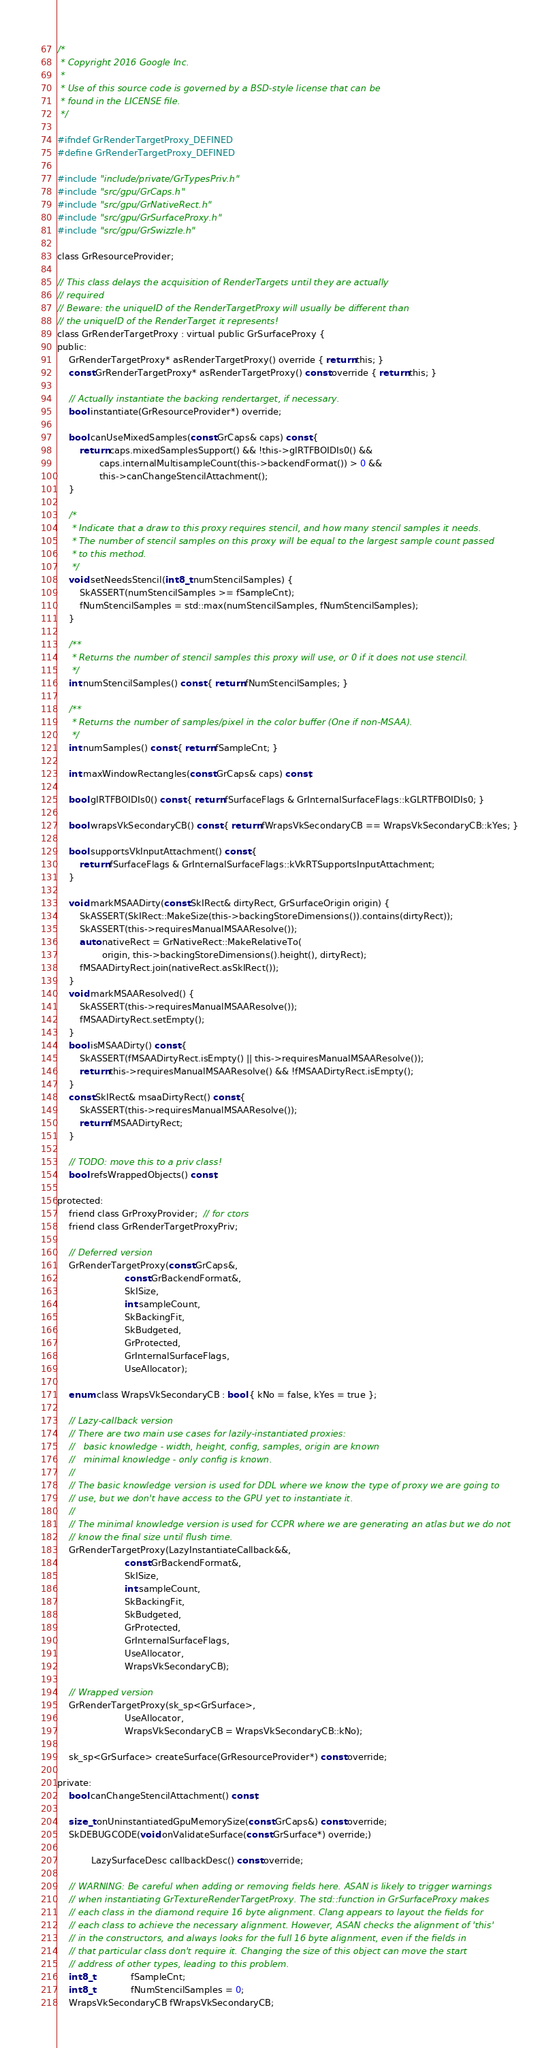Convert code to text. <code><loc_0><loc_0><loc_500><loc_500><_C_>/*
 * Copyright 2016 Google Inc.
 *
 * Use of this source code is governed by a BSD-style license that can be
 * found in the LICENSE file.
 */

#ifndef GrRenderTargetProxy_DEFINED
#define GrRenderTargetProxy_DEFINED

#include "include/private/GrTypesPriv.h"
#include "src/gpu/GrCaps.h"
#include "src/gpu/GrNativeRect.h"
#include "src/gpu/GrSurfaceProxy.h"
#include "src/gpu/GrSwizzle.h"

class GrResourceProvider;

// This class delays the acquisition of RenderTargets until they are actually
// required
// Beware: the uniqueID of the RenderTargetProxy will usually be different than
// the uniqueID of the RenderTarget it represents!
class GrRenderTargetProxy : virtual public GrSurfaceProxy {
public:
    GrRenderTargetProxy* asRenderTargetProxy() override { return this; }
    const GrRenderTargetProxy* asRenderTargetProxy() const override { return this; }

    // Actually instantiate the backing rendertarget, if necessary.
    bool instantiate(GrResourceProvider*) override;

    bool canUseMixedSamples(const GrCaps& caps) const {
        return caps.mixedSamplesSupport() && !this->glRTFBOIDIs0() &&
               caps.internalMultisampleCount(this->backendFormat()) > 0 &&
               this->canChangeStencilAttachment();
    }

    /*
     * Indicate that a draw to this proxy requires stencil, and how many stencil samples it needs.
     * The number of stencil samples on this proxy will be equal to the largest sample count passed
     * to this method.
     */
    void setNeedsStencil(int8_t numStencilSamples) {
        SkASSERT(numStencilSamples >= fSampleCnt);
        fNumStencilSamples = std::max(numStencilSamples, fNumStencilSamples);
    }

    /**
     * Returns the number of stencil samples this proxy will use, or 0 if it does not use stencil.
     */
    int numStencilSamples() const { return fNumStencilSamples; }

    /**
     * Returns the number of samples/pixel in the color buffer (One if non-MSAA).
     */
    int numSamples() const { return fSampleCnt; }

    int maxWindowRectangles(const GrCaps& caps) const;

    bool glRTFBOIDIs0() const { return fSurfaceFlags & GrInternalSurfaceFlags::kGLRTFBOIDIs0; }

    bool wrapsVkSecondaryCB() const { return fWrapsVkSecondaryCB == WrapsVkSecondaryCB::kYes; }

    bool supportsVkInputAttachment() const {
        return fSurfaceFlags & GrInternalSurfaceFlags::kVkRTSupportsInputAttachment;
    }

    void markMSAADirty(const SkIRect& dirtyRect, GrSurfaceOrigin origin) {
        SkASSERT(SkIRect::MakeSize(this->backingStoreDimensions()).contains(dirtyRect));
        SkASSERT(this->requiresManualMSAAResolve());
        auto nativeRect = GrNativeRect::MakeRelativeTo(
                origin, this->backingStoreDimensions().height(), dirtyRect);
        fMSAADirtyRect.join(nativeRect.asSkIRect());
    }
    void markMSAAResolved() {
        SkASSERT(this->requiresManualMSAAResolve());
        fMSAADirtyRect.setEmpty();
    }
    bool isMSAADirty() const {
        SkASSERT(fMSAADirtyRect.isEmpty() || this->requiresManualMSAAResolve());
        return this->requiresManualMSAAResolve() && !fMSAADirtyRect.isEmpty();
    }
    const SkIRect& msaaDirtyRect() const {
        SkASSERT(this->requiresManualMSAAResolve());
        return fMSAADirtyRect;
    }

    // TODO: move this to a priv class!
    bool refsWrappedObjects() const;

protected:
    friend class GrProxyProvider;  // for ctors
    friend class GrRenderTargetProxyPriv;

    // Deferred version
    GrRenderTargetProxy(const GrCaps&,
                        const GrBackendFormat&,
                        SkISize,
                        int sampleCount,
                        SkBackingFit,
                        SkBudgeted,
                        GrProtected,
                        GrInternalSurfaceFlags,
                        UseAllocator);

    enum class WrapsVkSecondaryCB : bool { kNo = false, kYes = true };

    // Lazy-callback version
    // There are two main use cases for lazily-instantiated proxies:
    //   basic knowledge - width, height, config, samples, origin are known
    //   minimal knowledge - only config is known.
    //
    // The basic knowledge version is used for DDL where we know the type of proxy we are going to
    // use, but we don't have access to the GPU yet to instantiate it.
    //
    // The minimal knowledge version is used for CCPR where we are generating an atlas but we do not
    // know the final size until flush time.
    GrRenderTargetProxy(LazyInstantiateCallback&&,
                        const GrBackendFormat&,
                        SkISize,
                        int sampleCount,
                        SkBackingFit,
                        SkBudgeted,
                        GrProtected,
                        GrInternalSurfaceFlags,
                        UseAllocator,
                        WrapsVkSecondaryCB);

    // Wrapped version
    GrRenderTargetProxy(sk_sp<GrSurface>,
                        UseAllocator,
                        WrapsVkSecondaryCB = WrapsVkSecondaryCB::kNo);

    sk_sp<GrSurface> createSurface(GrResourceProvider*) const override;

private:
    bool canChangeStencilAttachment() const;

    size_t onUninstantiatedGpuMemorySize(const GrCaps&) const override;
    SkDEBUGCODE(void onValidateSurface(const GrSurface*) override;)

            LazySurfaceDesc callbackDesc() const override;

    // WARNING: Be careful when adding or removing fields here. ASAN is likely to trigger warnings
    // when instantiating GrTextureRenderTargetProxy. The std::function in GrSurfaceProxy makes
    // each class in the diamond require 16 byte alignment. Clang appears to layout the fields for
    // each class to achieve the necessary alignment. However, ASAN checks the alignment of 'this'
    // in the constructors, and always looks for the full 16 byte alignment, even if the fields in
    // that particular class don't require it. Changing the size of this object can move the start
    // address of other types, leading to this problem.
    int8_t             fSampleCnt;
    int8_t             fNumStencilSamples = 0;
    WrapsVkSecondaryCB fWrapsVkSecondaryCB;</code> 